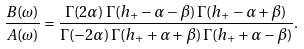<formula> <loc_0><loc_0><loc_500><loc_500>\frac { B ( \omega ) } { A ( \omega ) } = \frac { \Gamma ( 2 \alpha ) \, \Gamma ( h _ { + } - \alpha - \beta ) \, \Gamma ( h _ { + } - \alpha + \beta ) } { \Gamma ( - 2 \alpha ) \, \Gamma ( h _ { + } + \alpha + \beta ) \, \Gamma ( h _ { + } + \alpha - \beta ) } . \label l { B / A }</formula> 